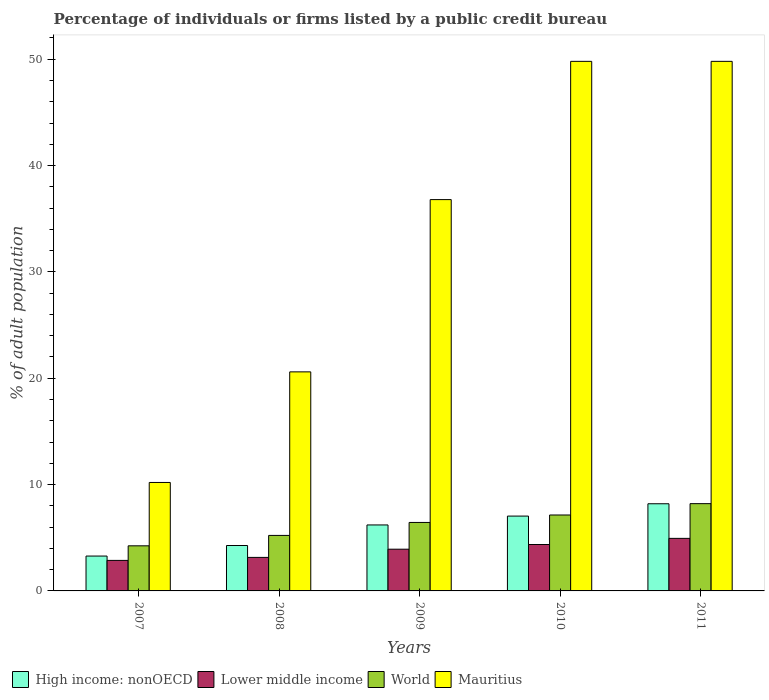How many different coloured bars are there?
Give a very brief answer. 4. How many groups of bars are there?
Your answer should be very brief. 5. Are the number of bars per tick equal to the number of legend labels?
Provide a succinct answer. Yes. Are the number of bars on each tick of the X-axis equal?
Make the answer very short. Yes. How many bars are there on the 1st tick from the left?
Keep it short and to the point. 4. In how many cases, is the number of bars for a given year not equal to the number of legend labels?
Your answer should be compact. 0. What is the percentage of population listed by a public credit bureau in World in 2007?
Provide a succinct answer. 4.24. Across all years, what is the maximum percentage of population listed by a public credit bureau in Lower middle income?
Your answer should be very brief. 4.94. Across all years, what is the minimum percentage of population listed by a public credit bureau in World?
Provide a short and direct response. 4.24. What is the total percentage of population listed by a public credit bureau in Mauritius in the graph?
Your answer should be very brief. 167.2. What is the difference between the percentage of population listed by a public credit bureau in Lower middle income in 2009 and that in 2011?
Ensure brevity in your answer.  -1.02. What is the difference between the percentage of population listed by a public credit bureau in World in 2008 and the percentage of population listed by a public credit bureau in High income: nonOECD in 2010?
Ensure brevity in your answer.  -1.82. What is the average percentage of population listed by a public credit bureau in High income: nonOECD per year?
Your answer should be very brief. 5.8. In the year 2011, what is the difference between the percentage of population listed by a public credit bureau in High income: nonOECD and percentage of population listed by a public credit bureau in Mauritius?
Give a very brief answer. -41.6. In how many years, is the percentage of population listed by a public credit bureau in High income: nonOECD greater than 8 %?
Give a very brief answer. 1. What is the ratio of the percentage of population listed by a public credit bureau in Mauritius in 2007 to that in 2010?
Provide a short and direct response. 0.2. Is the percentage of population listed by a public credit bureau in World in 2007 less than that in 2009?
Offer a very short reply. Yes. Is the difference between the percentage of population listed by a public credit bureau in High income: nonOECD in 2007 and 2008 greater than the difference between the percentage of population listed by a public credit bureau in Mauritius in 2007 and 2008?
Provide a short and direct response. Yes. What is the difference between the highest and the second highest percentage of population listed by a public credit bureau in High income: nonOECD?
Offer a very short reply. 1.16. What is the difference between the highest and the lowest percentage of population listed by a public credit bureau in High income: nonOECD?
Keep it short and to the point. 4.92. Is the sum of the percentage of population listed by a public credit bureau in Mauritius in 2009 and 2011 greater than the maximum percentage of population listed by a public credit bureau in World across all years?
Provide a succinct answer. Yes. Is it the case that in every year, the sum of the percentage of population listed by a public credit bureau in World and percentage of population listed by a public credit bureau in High income: nonOECD is greater than the sum of percentage of population listed by a public credit bureau in Lower middle income and percentage of population listed by a public credit bureau in Mauritius?
Ensure brevity in your answer.  No. What does the 3rd bar from the right in 2008 represents?
Your answer should be compact. Lower middle income. How many bars are there?
Your answer should be very brief. 20. Are all the bars in the graph horizontal?
Provide a succinct answer. No. Are the values on the major ticks of Y-axis written in scientific E-notation?
Offer a terse response. No. Does the graph contain any zero values?
Provide a succinct answer. No. Does the graph contain grids?
Keep it short and to the point. No. How are the legend labels stacked?
Make the answer very short. Horizontal. What is the title of the graph?
Offer a terse response. Percentage of individuals or firms listed by a public credit bureau. What is the label or title of the X-axis?
Make the answer very short. Years. What is the label or title of the Y-axis?
Keep it short and to the point. % of adult population. What is the % of adult population of High income: nonOECD in 2007?
Provide a short and direct response. 3.28. What is the % of adult population in Lower middle income in 2007?
Your answer should be very brief. 2.87. What is the % of adult population in World in 2007?
Offer a terse response. 4.24. What is the % of adult population in High income: nonOECD in 2008?
Give a very brief answer. 4.27. What is the % of adult population in Lower middle income in 2008?
Your answer should be compact. 3.15. What is the % of adult population of World in 2008?
Your answer should be compact. 5.22. What is the % of adult population of Mauritius in 2008?
Your answer should be very brief. 20.6. What is the % of adult population of High income: nonOECD in 2009?
Provide a succinct answer. 6.2. What is the % of adult population of Lower middle income in 2009?
Your answer should be very brief. 3.92. What is the % of adult population in World in 2009?
Your answer should be very brief. 6.44. What is the % of adult population of Mauritius in 2009?
Ensure brevity in your answer.  36.8. What is the % of adult population in High income: nonOECD in 2010?
Your answer should be compact. 7.04. What is the % of adult population in Lower middle income in 2010?
Your response must be concise. 4.36. What is the % of adult population in World in 2010?
Offer a terse response. 7.14. What is the % of adult population of Mauritius in 2010?
Offer a terse response. 49.8. What is the % of adult population of High income: nonOECD in 2011?
Ensure brevity in your answer.  8.2. What is the % of adult population in Lower middle income in 2011?
Keep it short and to the point. 4.94. What is the % of adult population in World in 2011?
Provide a succinct answer. 8.21. What is the % of adult population in Mauritius in 2011?
Your answer should be compact. 49.8. Across all years, what is the maximum % of adult population of High income: nonOECD?
Ensure brevity in your answer.  8.2. Across all years, what is the maximum % of adult population in Lower middle income?
Your answer should be very brief. 4.94. Across all years, what is the maximum % of adult population in World?
Your answer should be compact. 8.21. Across all years, what is the maximum % of adult population of Mauritius?
Provide a succinct answer. 49.8. Across all years, what is the minimum % of adult population of High income: nonOECD?
Make the answer very short. 3.28. Across all years, what is the minimum % of adult population in Lower middle income?
Offer a terse response. 2.87. Across all years, what is the minimum % of adult population of World?
Keep it short and to the point. 4.24. What is the total % of adult population in High income: nonOECD in the graph?
Provide a succinct answer. 28.99. What is the total % of adult population of Lower middle income in the graph?
Your answer should be very brief. 19.25. What is the total % of adult population in World in the graph?
Give a very brief answer. 31.25. What is the total % of adult population of Mauritius in the graph?
Give a very brief answer. 167.2. What is the difference between the % of adult population in High income: nonOECD in 2007 and that in 2008?
Offer a terse response. -0.99. What is the difference between the % of adult population in Lower middle income in 2007 and that in 2008?
Provide a succinct answer. -0.28. What is the difference between the % of adult population of World in 2007 and that in 2008?
Ensure brevity in your answer.  -0.98. What is the difference between the % of adult population of Mauritius in 2007 and that in 2008?
Ensure brevity in your answer.  -10.4. What is the difference between the % of adult population of High income: nonOECD in 2007 and that in 2009?
Make the answer very short. -2.93. What is the difference between the % of adult population in Lower middle income in 2007 and that in 2009?
Make the answer very short. -1.05. What is the difference between the % of adult population of World in 2007 and that in 2009?
Provide a short and direct response. -2.2. What is the difference between the % of adult population of Mauritius in 2007 and that in 2009?
Offer a terse response. -26.6. What is the difference between the % of adult population of High income: nonOECD in 2007 and that in 2010?
Your response must be concise. -3.76. What is the difference between the % of adult population of Lower middle income in 2007 and that in 2010?
Make the answer very short. -1.49. What is the difference between the % of adult population of World in 2007 and that in 2010?
Your answer should be compact. -2.9. What is the difference between the % of adult population in Mauritius in 2007 and that in 2010?
Offer a terse response. -39.6. What is the difference between the % of adult population in High income: nonOECD in 2007 and that in 2011?
Your answer should be compact. -4.92. What is the difference between the % of adult population of Lower middle income in 2007 and that in 2011?
Offer a terse response. -2.07. What is the difference between the % of adult population of World in 2007 and that in 2011?
Your answer should be compact. -3.97. What is the difference between the % of adult population of Mauritius in 2007 and that in 2011?
Provide a succinct answer. -39.6. What is the difference between the % of adult population of High income: nonOECD in 2008 and that in 2009?
Make the answer very short. -1.93. What is the difference between the % of adult population in Lower middle income in 2008 and that in 2009?
Make the answer very short. -0.77. What is the difference between the % of adult population of World in 2008 and that in 2009?
Provide a short and direct response. -1.22. What is the difference between the % of adult population of Mauritius in 2008 and that in 2009?
Your response must be concise. -16.2. What is the difference between the % of adult population in High income: nonOECD in 2008 and that in 2010?
Offer a terse response. -2.77. What is the difference between the % of adult population in Lower middle income in 2008 and that in 2010?
Make the answer very short. -1.21. What is the difference between the % of adult population in World in 2008 and that in 2010?
Your response must be concise. -1.92. What is the difference between the % of adult population in Mauritius in 2008 and that in 2010?
Ensure brevity in your answer.  -29.2. What is the difference between the % of adult population of High income: nonOECD in 2008 and that in 2011?
Offer a terse response. -3.93. What is the difference between the % of adult population of Lower middle income in 2008 and that in 2011?
Your answer should be very brief. -1.79. What is the difference between the % of adult population of World in 2008 and that in 2011?
Make the answer very short. -2.99. What is the difference between the % of adult population in Mauritius in 2008 and that in 2011?
Your response must be concise. -29.2. What is the difference between the % of adult population of Lower middle income in 2009 and that in 2010?
Offer a terse response. -0.44. What is the difference between the % of adult population of High income: nonOECD in 2009 and that in 2011?
Ensure brevity in your answer.  -1.99. What is the difference between the % of adult population in Lower middle income in 2009 and that in 2011?
Your answer should be compact. -1.02. What is the difference between the % of adult population of World in 2009 and that in 2011?
Ensure brevity in your answer.  -1.77. What is the difference between the % of adult population of Mauritius in 2009 and that in 2011?
Offer a terse response. -13. What is the difference between the % of adult population of High income: nonOECD in 2010 and that in 2011?
Your answer should be compact. -1.16. What is the difference between the % of adult population of Lower middle income in 2010 and that in 2011?
Provide a short and direct response. -0.58. What is the difference between the % of adult population in World in 2010 and that in 2011?
Give a very brief answer. -1.07. What is the difference between the % of adult population of High income: nonOECD in 2007 and the % of adult population of Lower middle income in 2008?
Offer a very short reply. 0.13. What is the difference between the % of adult population of High income: nonOECD in 2007 and the % of adult population of World in 2008?
Your response must be concise. -1.94. What is the difference between the % of adult population in High income: nonOECD in 2007 and the % of adult population in Mauritius in 2008?
Your answer should be compact. -17.32. What is the difference between the % of adult population in Lower middle income in 2007 and the % of adult population in World in 2008?
Your answer should be very brief. -2.35. What is the difference between the % of adult population of Lower middle income in 2007 and the % of adult population of Mauritius in 2008?
Make the answer very short. -17.73. What is the difference between the % of adult population in World in 2007 and the % of adult population in Mauritius in 2008?
Keep it short and to the point. -16.36. What is the difference between the % of adult population in High income: nonOECD in 2007 and the % of adult population in Lower middle income in 2009?
Provide a succinct answer. -0.65. What is the difference between the % of adult population in High income: nonOECD in 2007 and the % of adult population in World in 2009?
Your answer should be very brief. -3.16. What is the difference between the % of adult population in High income: nonOECD in 2007 and the % of adult population in Mauritius in 2009?
Give a very brief answer. -33.52. What is the difference between the % of adult population of Lower middle income in 2007 and the % of adult population of World in 2009?
Ensure brevity in your answer.  -3.57. What is the difference between the % of adult population in Lower middle income in 2007 and the % of adult population in Mauritius in 2009?
Ensure brevity in your answer.  -33.93. What is the difference between the % of adult population in World in 2007 and the % of adult population in Mauritius in 2009?
Offer a very short reply. -32.56. What is the difference between the % of adult population of High income: nonOECD in 2007 and the % of adult population of Lower middle income in 2010?
Your answer should be very brief. -1.09. What is the difference between the % of adult population of High income: nonOECD in 2007 and the % of adult population of World in 2010?
Provide a succinct answer. -3.86. What is the difference between the % of adult population of High income: nonOECD in 2007 and the % of adult population of Mauritius in 2010?
Provide a short and direct response. -46.52. What is the difference between the % of adult population in Lower middle income in 2007 and the % of adult population in World in 2010?
Offer a terse response. -4.27. What is the difference between the % of adult population of Lower middle income in 2007 and the % of adult population of Mauritius in 2010?
Offer a terse response. -46.93. What is the difference between the % of adult population of World in 2007 and the % of adult population of Mauritius in 2010?
Your answer should be very brief. -45.56. What is the difference between the % of adult population in High income: nonOECD in 2007 and the % of adult population in Lower middle income in 2011?
Provide a succinct answer. -1.66. What is the difference between the % of adult population in High income: nonOECD in 2007 and the % of adult population in World in 2011?
Offer a very short reply. -4.93. What is the difference between the % of adult population of High income: nonOECD in 2007 and the % of adult population of Mauritius in 2011?
Your answer should be very brief. -46.52. What is the difference between the % of adult population of Lower middle income in 2007 and the % of adult population of World in 2011?
Offer a very short reply. -5.34. What is the difference between the % of adult population of Lower middle income in 2007 and the % of adult population of Mauritius in 2011?
Your answer should be very brief. -46.93. What is the difference between the % of adult population in World in 2007 and the % of adult population in Mauritius in 2011?
Provide a succinct answer. -45.56. What is the difference between the % of adult population in High income: nonOECD in 2008 and the % of adult population in Lower middle income in 2009?
Give a very brief answer. 0.35. What is the difference between the % of adult population of High income: nonOECD in 2008 and the % of adult population of World in 2009?
Your answer should be compact. -2.17. What is the difference between the % of adult population in High income: nonOECD in 2008 and the % of adult population in Mauritius in 2009?
Offer a very short reply. -32.53. What is the difference between the % of adult population of Lower middle income in 2008 and the % of adult population of World in 2009?
Make the answer very short. -3.29. What is the difference between the % of adult population of Lower middle income in 2008 and the % of adult population of Mauritius in 2009?
Keep it short and to the point. -33.65. What is the difference between the % of adult population in World in 2008 and the % of adult population in Mauritius in 2009?
Make the answer very short. -31.58. What is the difference between the % of adult population in High income: nonOECD in 2008 and the % of adult population in Lower middle income in 2010?
Your answer should be very brief. -0.09. What is the difference between the % of adult population in High income: nonOECD in 2008 and the % of adult population in World in 2010?
Make the answer very short. -2.87. What is the difference between the % of adult population in High income: nonOECD in 2008 and the % of adult population in Mauritius in 2010?
Your response must be concise. -45.53. What is the difference between the % of adult population of Lower middle income in 2008 and the % of adult population of World in 2010?
Offer a very short reply. -3.99. What is the difference between the % of adult population of Lower middle income in 2008 and the % of adult population of Mauritius in 2010?
Provide a short and direct response. -46.65. What is the difference between the % of adult population in World in 2008 and the % of adult population in Mauritius in 2010?
Your answer should be very brief. -44.58. What is the difference between the % of adult population of High income: nonOECD in 2008 and the % of adult population of Lower middle income in 2011?
Your answer should be very brief. -0.67. What is the difference between the % of adult population in High income: nonOECD in 2008 and the % of adult population in World in 2011?
Provide a succinct answer. -3.94. What is the difference between the % of adult population of High income: nonOECD in 2008 and the % of adult population of Mauritius in 2011?
Give a very brief answer. -45.53. What is the difference between the % of adult population in Lower middle income in 2008 and the % of adult population in World in 2011?
Keep it short and to the point. -5.06. What is the difference between the % of adult population in Lower middle income in 2008 and the % of adult population in Mauritius in 2011?
Offer a very short reply. -46.65. What is the difference between the % of adult population in World in 2008 and the % of adult population in Mauritius in 2011?
Offer a very short reply. -44.58. What is the difference between the % of adult population of High income: nonOECD in 2009 and the % of adult population of Lower middle income in 2010?
Keep it short and to the point. 1.84. What is the difference between the % of adult population of High income: nonOECD in 2009 and the % of adult population of World in 2010?
Keep it short and to the point. -0.94. What is the difference between the % of adult population in High income: nonOECD in 2009 and the % of adult population in Mauritius in 2010?
Make the answer very short. -43.6. What is the difference between the % of adult population of Lower middle income in 2009 and the % of adult population of World in 2010?
Offer a terse response. -3.22. What is the difference between the % of adult population in Lower middle income in 2009 and the % of adult population in Mauritius in 2010?
Your answer should be very brief. -45.88. What is the difference between the % of adult population of World in 2009 and the % of adult population of Mauritius in 2010?
Offer a terse response. -43.36. What is the difference between the % of adult population of High income: nonOECD in 2009 and the % of adult population of Lower middle income in 2011?
Your answer should be very brief. 1.26. What is the difference between the % of adult population in High income: nonOECD in 2009 and the % of adult population in World in 2011?
Give a very brief answer. -2. What is the difference between the % of adult population of High income: nonOECD in 2009 and the % of adult population of Mauritius in 2011?
Your answer should be very brief. -43.6. What is the difference between the % of adult population in Lower middle income in 2009 and the % of adult population in World in 2011?
Your answer should be very brief. -4.28. What is the difference between the % of adult population in Lower middle income in 2009 and the % of adult population in Mauritius in 2011?
Your answer should be compact. -45.88. What is the difference between the % of adult population of World in 2009 and the % of adult population of Mauritius in 2011?
Your response must be concise. -43.36. What is the difference between the % of adult population in High income: nonOECD in 2010 and the % of adult population in Lower middle income in 2011?
Offer a very short reply. 2.1. What is the difference between the % of adult population in High income: nonOECD in 2010 and the % of adult population in World in 2011?
Provide a succinct answer. -1.17. What is the difference between the % of adult population in High income: nonOECD in 2010 and the % of adult population in Mauritius in 2011?
Offer a very short reply. -42.76. What is the difference between the % of adult population in Lower middle income in 2010 and the % of adult population in World in 2011?
Keep it short and to the point. -3.84. What is the difference between the % of adult population of Lower middle income in 2010 and the % of adult population of Mauritius in 2011?
Offer a very short reply. -45.44. What is the difference between the % of adult population in World in 2010 and the % of adult population in Mauritius in 2011?
Provide a succinct answer. -42.66. What is the average % of adult population in High income: nonOECD per year?
Offer a terse response. 5.8. What is the average % of adult population of Lower middle income per year?
Provide a succinct answer. 3.85. What is the average % of adult population in World per year?
Give a very brief answer. 6.25. What is the average % of adult population in Mauritius per year?
Keep it short and to the point. 33.44. In the year 2007, what is the difference between the % of adult population in High income: nonOECD and % of adult population in Lower middle income?
Offer a terse response. 0.41. In the year 2007, what is the difference between the % of adult population in High income: nonOECD and % of adult population in World?
Offer a terse response. -0.96. In the year 2007, what is the difference between the % of adult population in High income: nonOECD and % of adult population in Mauritius?
Your response must be concise. -6.92. In the year 2007, what is the difference between the % of adult population in Lower middle income and % of adult population in World?
Offer a very short reply. -1.37. In the year 2007, what is the difference between the % of adult population of Lower middle income and % of adult population of Mauritius?
Ensure brevity in your answer.  -7.33. In the year 2007, what is the difference between the % of adult population in World and % of adult population in Mauritius?
Provide a short and direct response. -5.96. In the year 2008, what is the difference between the % of adult population in High income: nonOECD and % of adult population in Lower middle income?
Offer a terse response. 1.12. In the year 2008, what is the difference between the % of adult population in High income: nonOECD and % of adult population in World?
Provide a succinct answer. -0.95. In the year 2008, what is the difference between the % of adult population of High income: nonOECD and % of adult population of Mauritius?
Your response must be concise. -16.33. In the year 2008, what is the difference between the % of adult population in Lower middle income and % of adult population in World?
Provide a short and direct response. -2.07. In the year 2008, what is the difference between the % of adult population in Lower middle income and % of adult population in Mauritius?
Give a very brief answer. -17.45. In the year 2008, what is the difference between the % of adult population in World and % of adult population in Mauritius?
Provide a short and direct response. -15.38. In the year 2009, what is the difference between the % of adult population of High income: nonOECD and % of adult population of Lower middle income?
Provide a succinct answer. 2.28. In the year 2009, what is the difference between the % of adult population in High income: nonOECD and % of adult population in World?
Your answer should be compact. -0.24. In the year 2009, what is the difference between the % of adult population of High income: nonOECD and % of adult population of Mauritius?
Ensure brevity in your answer.  -30.6. In the year 2009, what is the difference between the % of adult population of Lower middle income and % of adult population of World?
Your response must be concise. -2.52. In the year 2009, what is the difference between the % of adult population in Lower middle income and % of adult population in Mauritius?
Make the answer very short. -32.88. In the year 2009, what is the difference between the % of adult population in World and % of adult population in Mauritius?
Offer a terse response. -30.36. In the year 2010, what is the difference between the % of adult population in High income: nonOECD and % of adult population in Lower middle income?
Provide a succinct answer. 2.67. In the year 2010, what is the difference between the % of adult population of High income: nonOECD and % of adult population of World?
Offer a very short reply. -0.1. In the year 2010, what is the difference between the % of adult population of High income: nonOECD and % of adult population of Mauritius?
Your answer should be very brief. -42.76. In the year 2010, what is the difference between the % of adult population of Lower middle income and % of adult population of World?
Your response must be concise. -2.78. In the year 2010, what is the difference between the % of adult population in Lower middle income and % of adult population in Mauritius?
Your response must be concise. -45.44. In the year 2010, what is the difference between the % of adult population in World and % of adult population in Mauritius?
Give a very brief answer. -42.66. In the year 2011, what is the difference between the % of adult population in High income: nonOECD and % of adult population in Lower middle income?
Provide a short and direct response. 3.25. In the year 2011, what is the difference between the % of adult population in High income: nonOECD and % of adult population in World?
Provide a short and direct response. -0.01. In the year 2011, what is the difference between the % of adult population in High income: nonOECD and % of adult population in Mauritius?
Offer a terse response. -41.6. In the year 2011, what is the difference between the % of adult population in Lower middle income and % of adult population in World?
Provide a short and direct response. -3.27. In the year 2011, what is the difference between the % of adult population in Lower middle income and % of adult population in Mauritius?
Provide a short and direct response. -44.86. In the year 2011, what is the difference between the % of adult population in World and % of adult population in Mauritius?
Your answer should be compact. -41.59. What is the ratio of the % of adult population of High income: nonOECD in 2007 to that in 2008?
Your answer should be very brief. 0.77. What is the ratio of the % of adult population of Lower middle income in 2007 to that in 2008?
Make the answer very short. 0.91. What is the ratio of the % of adult population of World in 2007 to that in 2008?
Your answer should be compact. 0.81. What is the ratio of the % of adult population of Mauritius in 2007 to that in 2008?
Give a very brief answer. 0.5. What is the ratio of the % of adult population in High income: nonOECD in 2007 to that in 2009?
Keep it short and to the point. 0.53. What is the ratio of the % of adult population in Lower middle income in 2007 to that in 2009?
Ensure brevity in your answer.  0.73. What is the ratio of the % of adult population in World in 2007 to that in 2009?
Offer a terse response. 0.66. What is the ratio of the % of adult population in Mauritius in 2007 to that in 2009?
Your response must be concise. 0.28. What is the ratio of the % of adult population in High income: nonOECD in 2007 to that in 2010?
Your answer should be compact. 0.47. What is the ratio of the % of adult population in Lower middle income in 2007 to that in 2010?
Offer a very short reply. 0.66. What is the ratio of the % of adult population of World in 2007 to that in 2010?
Offer a very short reply. 0.59. What is the ratio of the % of adult population of Mauritius in 2007 to that in 2010?
Make the answer very short. 0.2. What is the ratio of the % of adult population in Lower middle income in 2007 to that in 2011?
Ensure brevity in your answer.  0.58. What is the ratio of the % of adult population of World in 2007 to that in 2011?
Offer a very short reply. 0.52. What is the ratio of the % of adult population in Mauritius in 2007 to that in 2011?
Ensure brevity in your answer.  0.2. What is the ratio of the % of adult population in High income: nonOECD in 2008 to that in 2009?
Keep it short and to the point. 0.69. What is the ratio of the % of adult population of Lower middle income in 2008 to that in 2009?
Offer a very short reply. 0.8. What is the ratio of the % of adult population in World in 2008 to that in 2009?
Make the answer very short. 0.81. What is the ratio of the % of adult population of Mauritius in 2008 to that in 2009?
Provide a succinct answer. 0.56. What is the ratio of the % of adult population of High income: nonOECD in 2008 to that in 2010?
Give a very brief answer. 0.61. What is the ratio of the % of adult population of Lower middle income in 2008 to that in 2010?
Your response must be concise. 0.72. What is the ratio of the % of adult population of World in 2008 to that in 2010?
Offer a terse response. 0.73. What is the ratio of the % of adult population in Mauritius in 2008 to that in 2010?
Provide a short and direct response. 0.41. What is the ratio of the % of adult population in High income: nonOECD in 2008 to that in 2011?
Provide a short and direct response. 0.52. What is the ratio of the % of adult population of Lower middle income in 2008 to that in 2011?
Provide a succinct answer. 0.64. What is the ratio of the % of adult population of World in 2008 to that in 2011?
Offer a terse response. 0.64. What is the ratio of the % of adult population in Mauritius in 2008 to that in 2011?
Ensure brevity in your answer.  0.41. What is the ratio of the % of adult population of High income: nonOECD in 2009 to that in 2010?
Offer a terse response. 0.88. What is the ratio of the % of adult population of Lower middle income in 2009 to that in 2010?
Give a very brief answer. 0.9. What is the ratio of the % of adult population of World in 2009 to that in 2010?
Offer a very short reply. 0.9. What is the ratio of the % of adult population of Mauritius in 2009 to that in 2010?
Your response must be concise. 0.74. What is the ratio of the % of adult population of High income: nonOECD in 2009 to that in 2011?
Your answer should be very brief. 0.76. What is the ratio of the % of adult population in Lower middle income in 2009 to that in 2011?
Provide a succinct answer. 0.79. What is the ratio of the % of adult population in World in 2009 to that in 2011?
Provide a succinct answer. 0.78. What is the ratio of the % of adult population of Mauritius in 2009 to that in 2011?
Keep it short and to the point. 0.74. What is the ratio of the % of adult population of High income: nonOECD in 2010 to that in 2011?
Offer a very short reply. 0.86. What is the ratio of the % of adult population of Lower middle income in 2010 to that in 2011?
Make the answer very short. 0.88. What is the ratio of the % of adult population of World in 2010 to that in 2011?
Offer a terse response. 0.87. What is the ratio of the % of adult population of Mauritius in 2010 to that in 2011?
Make the answer very short. 1. What is the difference between the highest and the second highest % of adult population of High income: nonOECD?
Your answer should be compact. 1.16. What is the difference between the highest and the second highest % of adult population in Lower middle income?
Your answer should be very brief. 0.58. What is the difference between the highest and the second highest % of adult population in World?
Provide a short and direct response. 1.07. What is the difference between the highest and the lowest % of adult population of High income: nonOECD?
Give a very brief answer. 4.92. What is the difference between the highest and the lowest % of adult population of Lower middle income?
Your answer should be very brief. 2.07. What is the difference between the highest and the lowest % of adult population of World?
Offer a terse response. 3.97. What is the difference between the highest and the lowest % of adult population of Mauritius?
Provide a short and direct response. 39.6. 